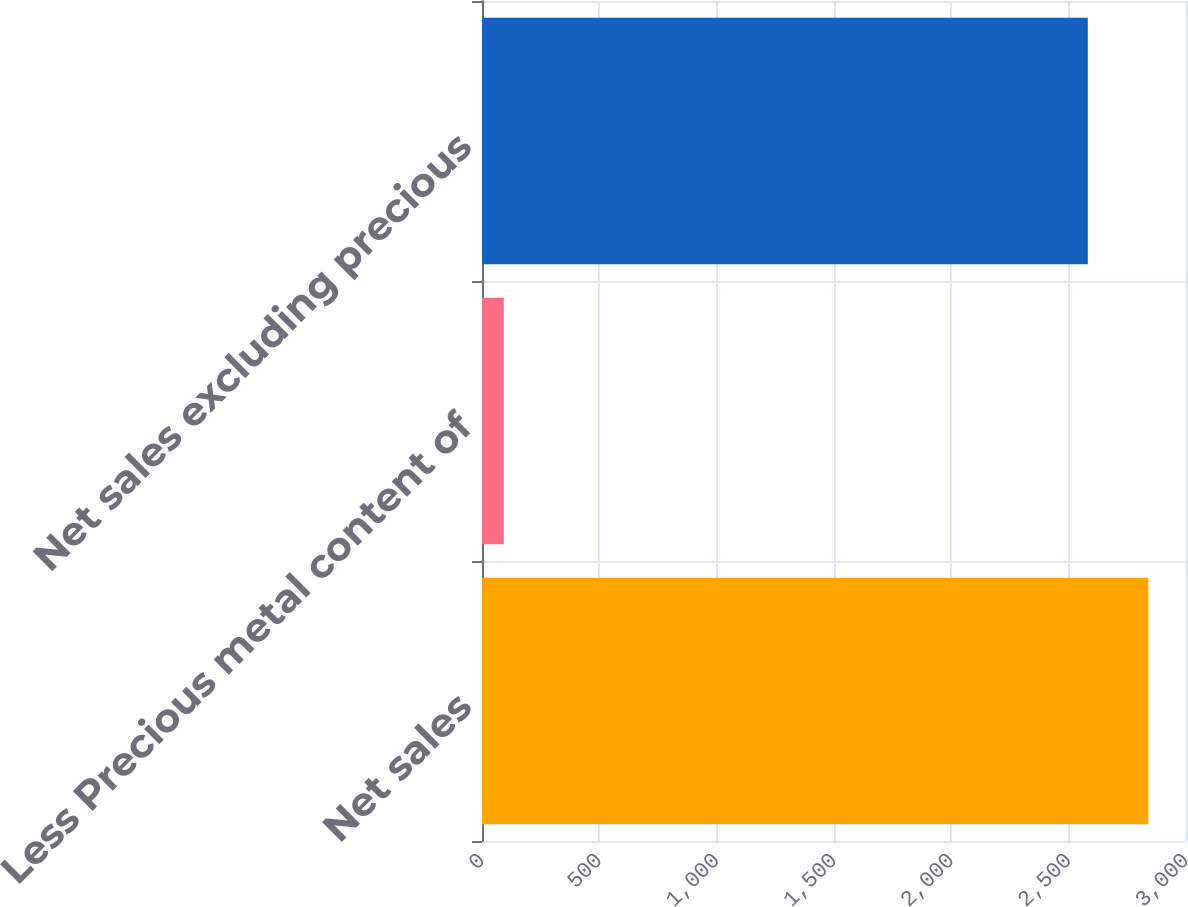Convert chart to OTSL. <chart><loc_0><loc_0><loc_500><loc_500><bar_chart><fcel>Net sales<fcel>Less Precious metal content of<fcel>Net sales excluding precious<nl><fcel>2839.65<fcel>92.8<fcel>2581.5<nl></chart> 